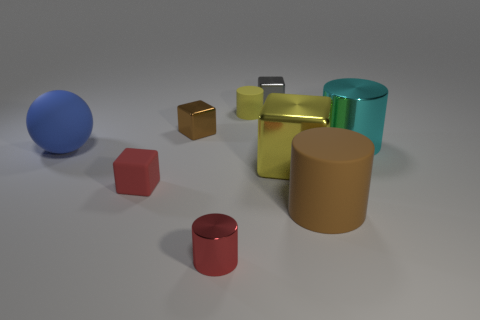There is a small gray block behind the small cylinder in front of the large shiny block; what number of small red objects are behind it?
Your answer should be very brief. 0. There is a large yellow metal object; what shape is it?
Give a very brief answer. Cube. What number of other things are there of the same material as the tiny gray object
Make the answer very short. 4. Is the brown rubber cylinder the same size as the red cube?
Make the answer very short. No. What shape is the thing that is left of the tiny red cube?
Ensure brevity in your answer.  Sphere. There is a matte object that is behind the large cylinder behind the matte block; what is its color?
Your response must be concise. Yellow. Is the shape of the large rubber thing that is behind the large brown rubber thing the same as the small matte object that is to the left of the small red metallic object?
Your response must be concise. No. What shape is the cyan shiny thing that is the same size as the yellow block?
Offer a very short reply. Cylinder. What is the color of the other big object that is made of the same material as the big yellow object?
Your response must be concise. Cyan. Does the brown rubber thing have the same shape as the yellow object in front of the large blue ball?
Offer a very short reply. No. 